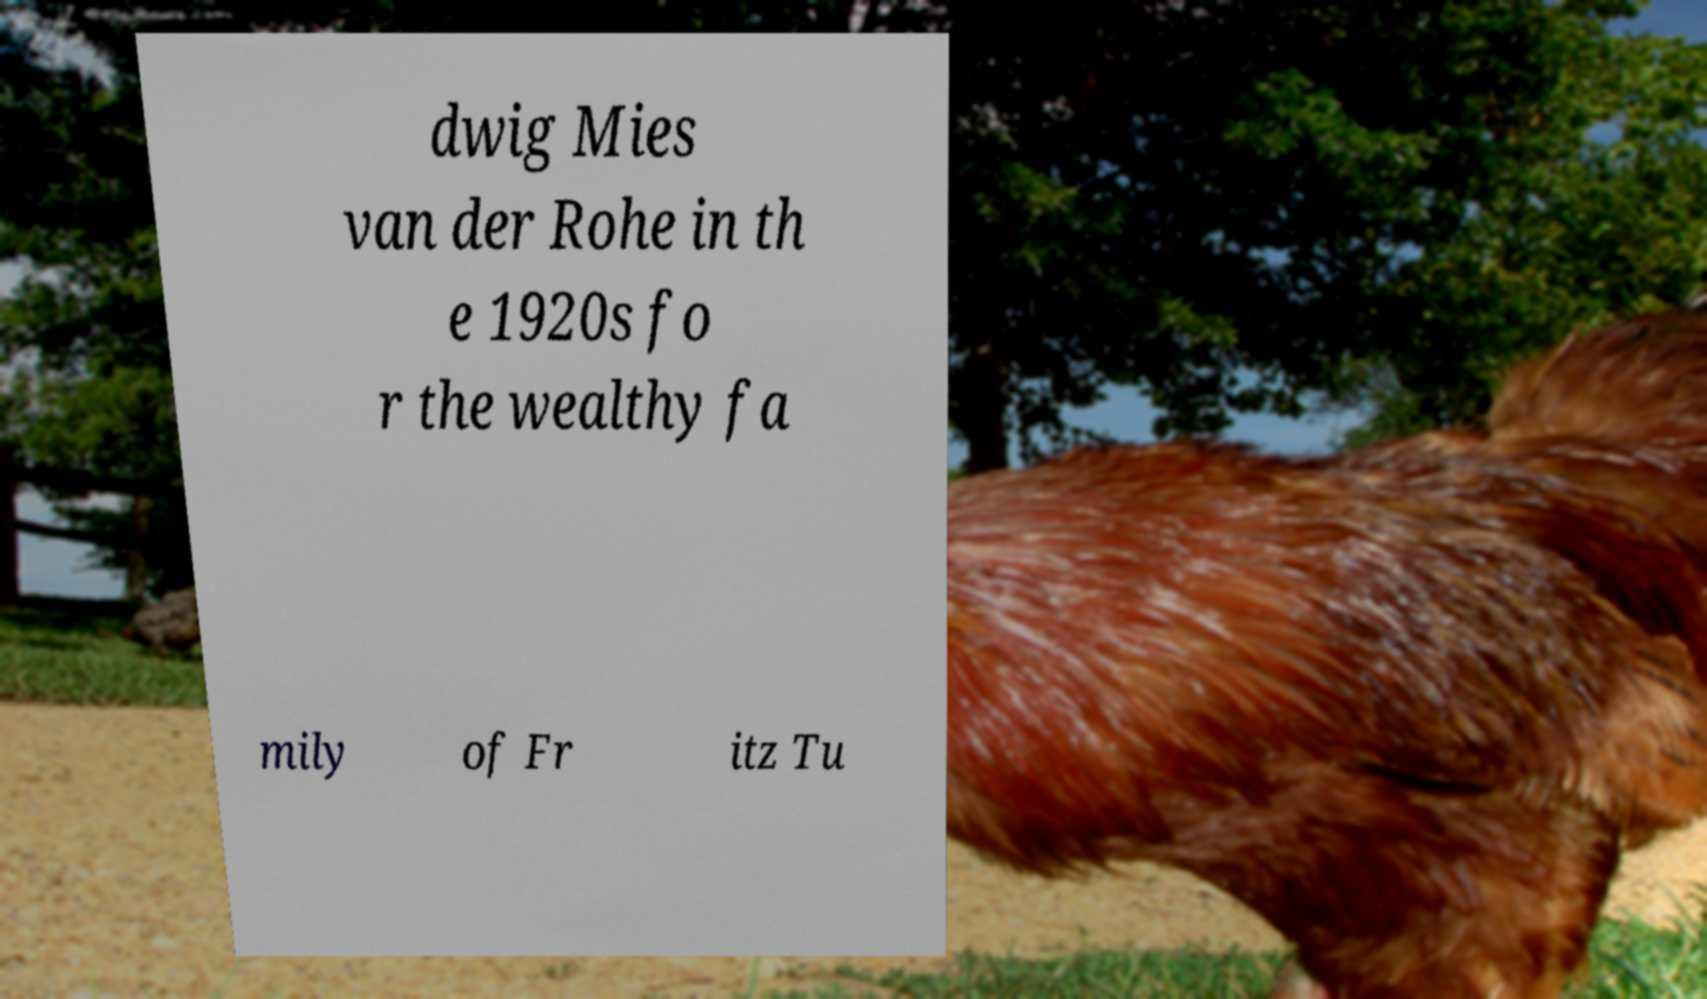Please identify and transcribe the text found in this image. dwig Mies van der Rohe in th e 1920s fo r the wealthy fa mily of Fr itz Tu 